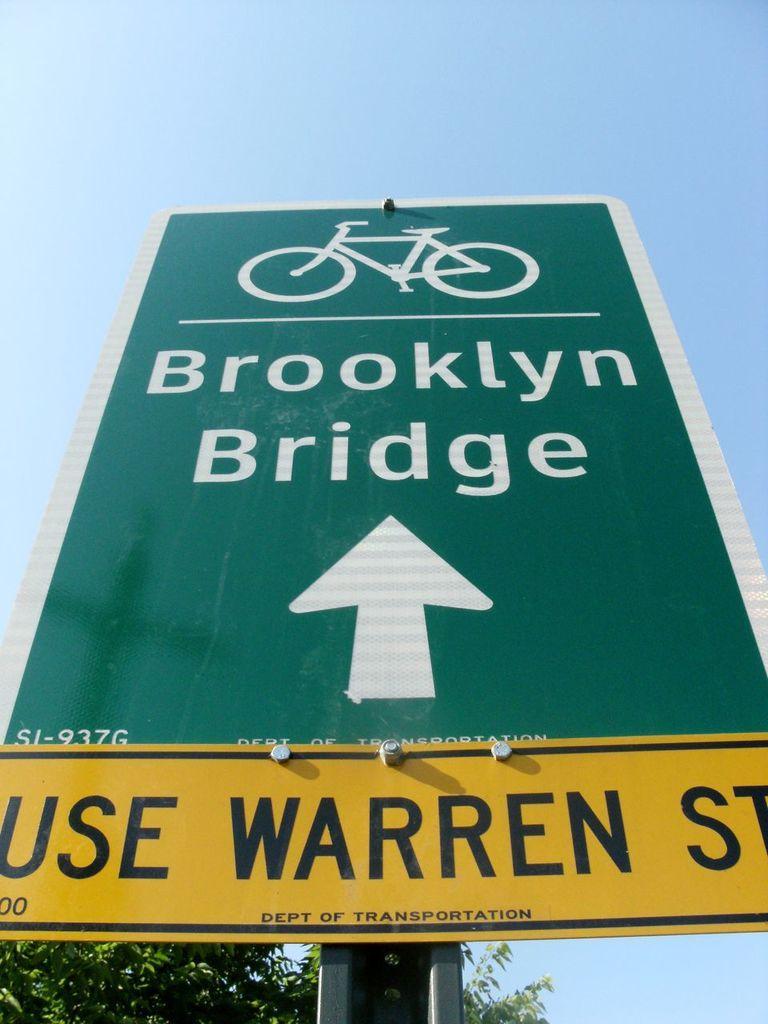Provide a one-sentence caption for the provided image. A green sign for bicycles for the Brooklyn Bridge on top of a yellow sign that says Use Warren St. 